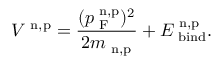Convert formula to latex. <formula><loc_0><loc_0><loc_500><loc_500>V ^ { n , p } = \frac { ( p _ { F } ^ { n , p } ) ^ { 2 } } { 2 m _ { n , p } } + E _ { b i n d } ^ { n , p } .</formula> 